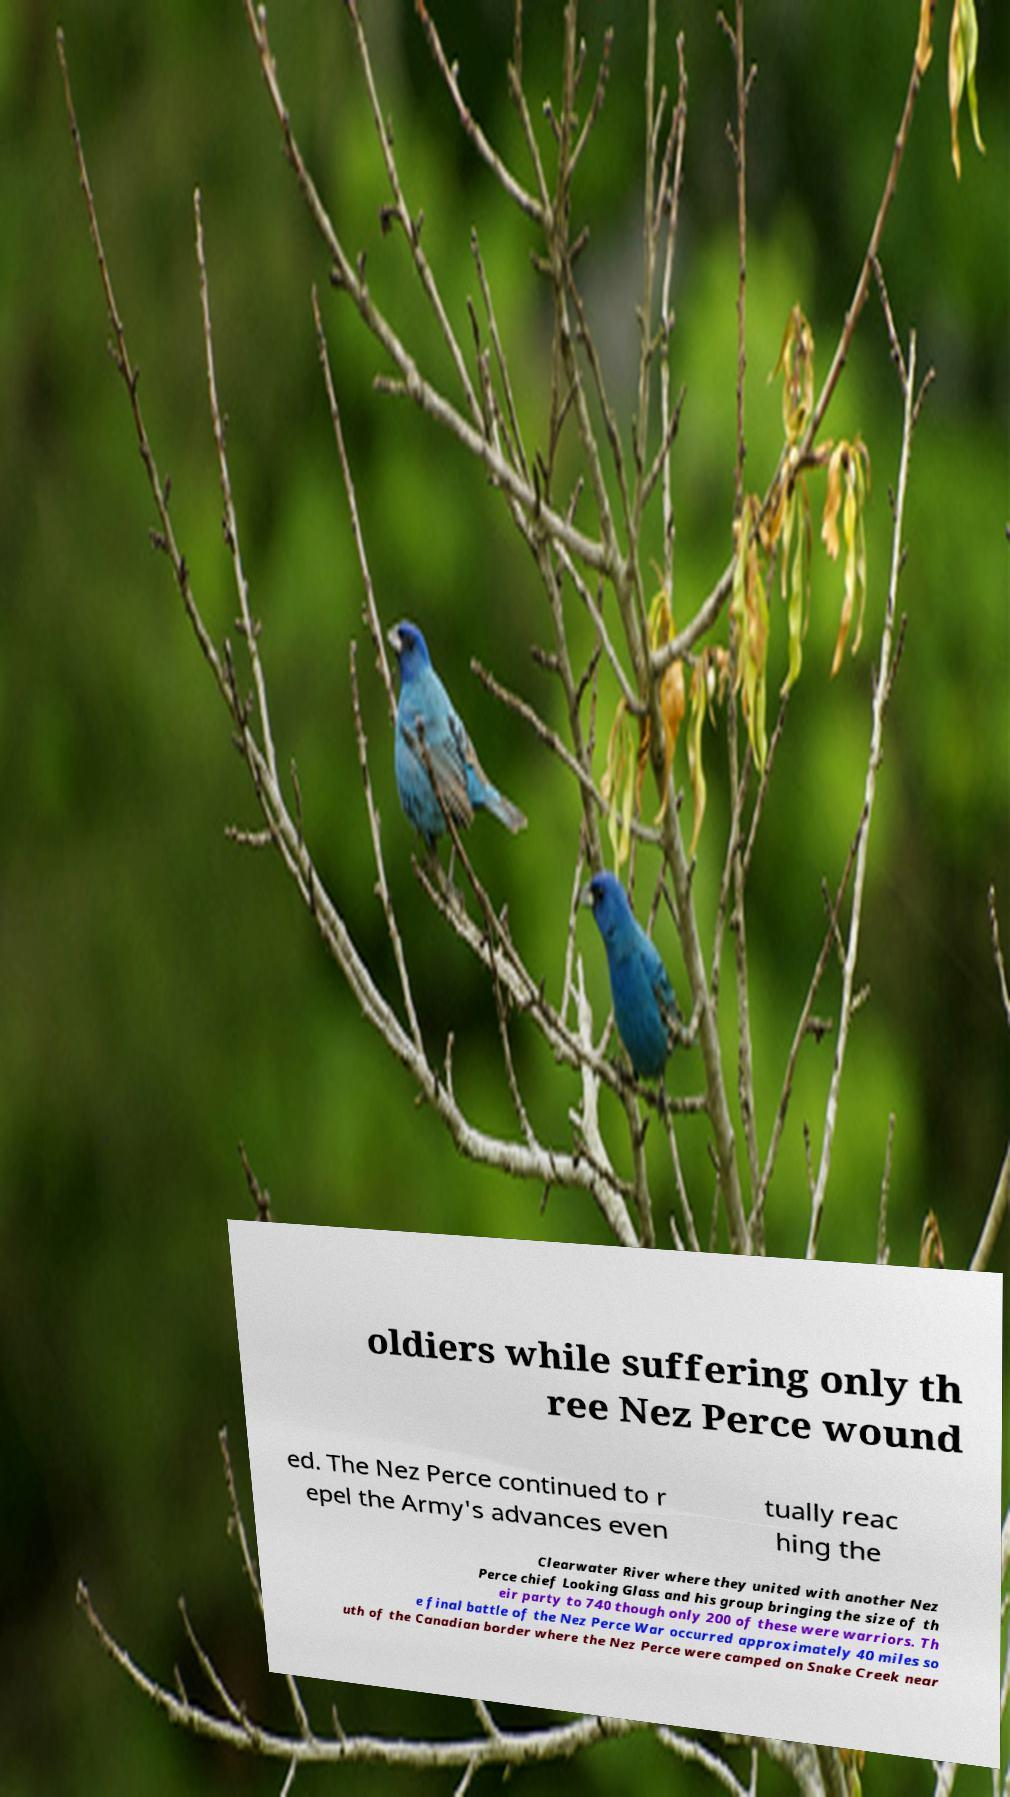I need the written content from this picture converted into text. Can you do that? oldiers while suffering only th ree Nez Perce wound ed. The Nez Perce continued to r epel the Army's advances even tually reac hing the Clearwater River where they united with another Nez Perce chief Looking Glass and his group bringing the size of th eir party to 740 though only 200 of these were warriors. Th e final battle of the Nez Perce War occurred approximately 40 miles so uth of the Canadian border where the Nez Perce were camped on Snake Creek near 